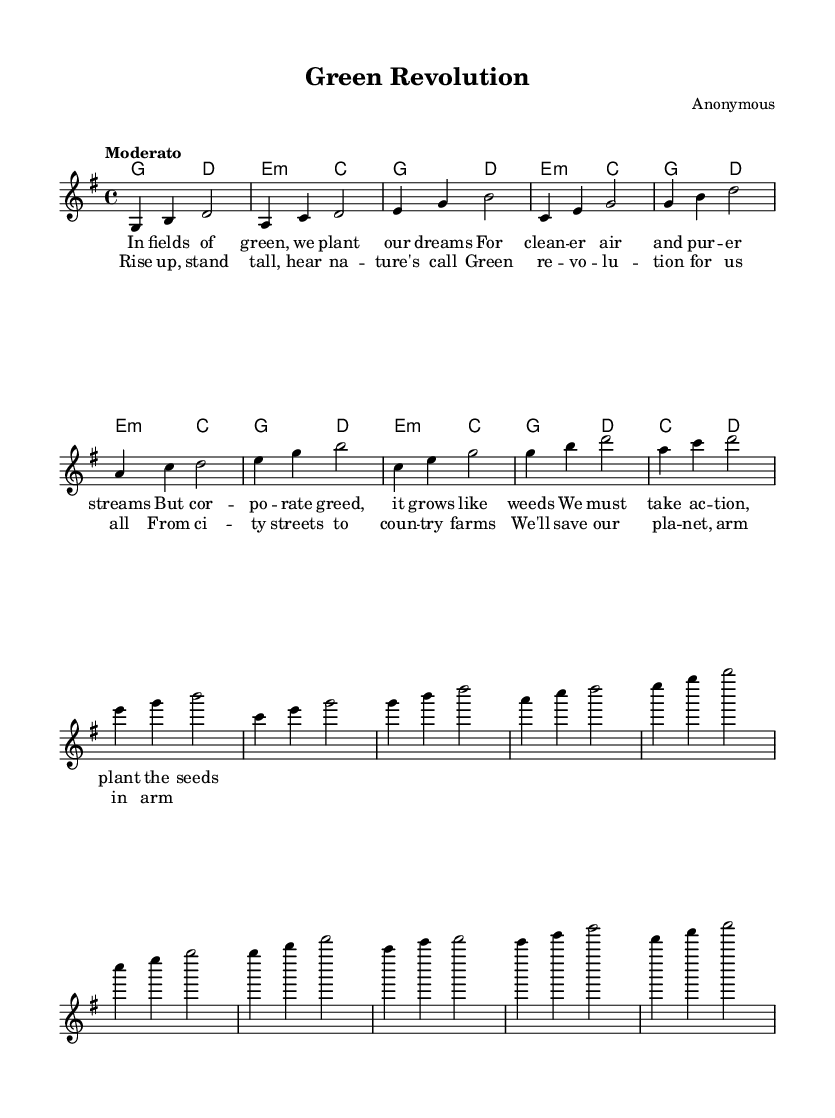What is the key signature of this music? The key signature indicates that the piece is in G major, which contains one sharp (F#) in its scale. This is found at the beginning of the music sheet, right after the clef.
Answer: G major What is the time signature? The time signature is displayed directly on the left side of the staff, indicating how beats are counted in each measure. In this case, it shows 4/4, meaning there are four beats per measure and the quarter note gets one beat.
Answer: 4/4 What is the tempo marking given in this music? The tempo marking is found above the staff at the start of the piece, indicating the speed at which the music should be played. It states "Moderato," suggesting a moderate pace.
Answer: Moderato How many measures are in the chorus section? To determine the number of measures in the chorus, we can count the distinct measure segments present in that part of the sheet music. The chorus section is clearly separated and consists of four measures.
Answer: Four What is the primary theme or message of the lyrics in the verse? The verse lyrics discuss themes of environmental concerns, including the intention of planting dreams for cleaner air and streams while addressing corporate greed. This is identified by reading through the lyrical content.
Answer: Environmental concerns What type of chord progression is used throughout the chorus? By analyzing the harmony section, we observe that there is a repeated chord progression of g, d, e minor, and c, creating a cycle that supports the melody. This progression complements the folksy feel typical of protest songs.
Answer: g, d, e minor, c What specific folk influence is reflected in the structure of the song? The structure features a repetitive chorus and verses that build on a strong call to action. This is characteristic of folk protest songs, as they aim to mobilize listeners, create a sense of community, and emphasize social issues. This points to its folk roots.
Answer: Call to action 